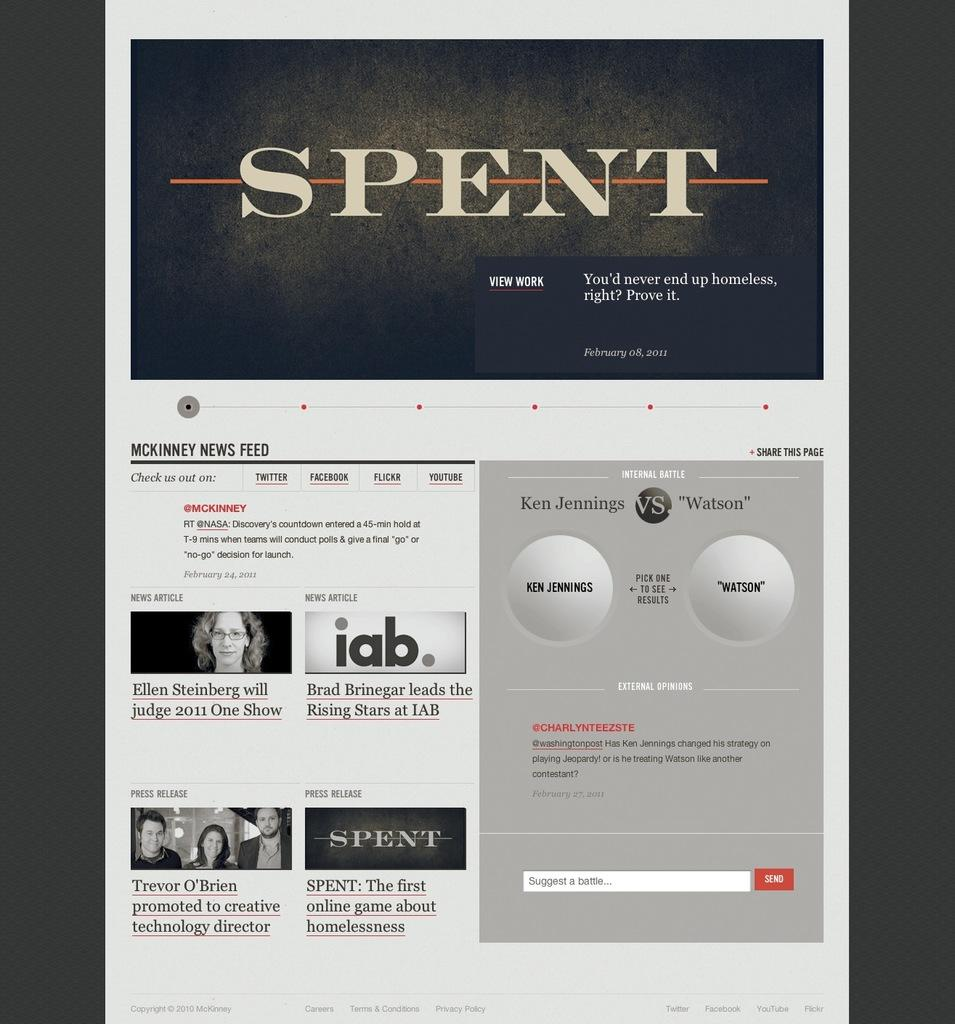What is the main object in the image? There is a poster or screen in the image. What can be seen on the poster or screen? Images of persons are in the bottom left of the image. What type of trouble can be seen in the image? There is no indication of trouble in the image; it features a poster or screen with images of persons. Can you see a dock in the image? There is no dock present in the image. 